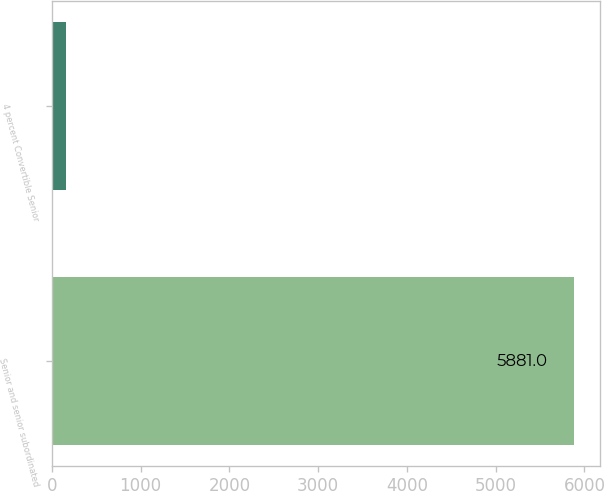Convert chart. <chart><loc_0><loc_0><loc_500><loc_500><bar_chart><fcel>Senior and senior subordinated<fcel>4 percent Convertible Senior<nl><fcel>5881<fcel>155<nl></chart> 